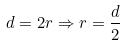Convert formula to latex. <formula><loc_0><loc_0><loc_500><loc_500>d = 2 r \Rightarrow r = \frac { d } { 2 }</formula> 